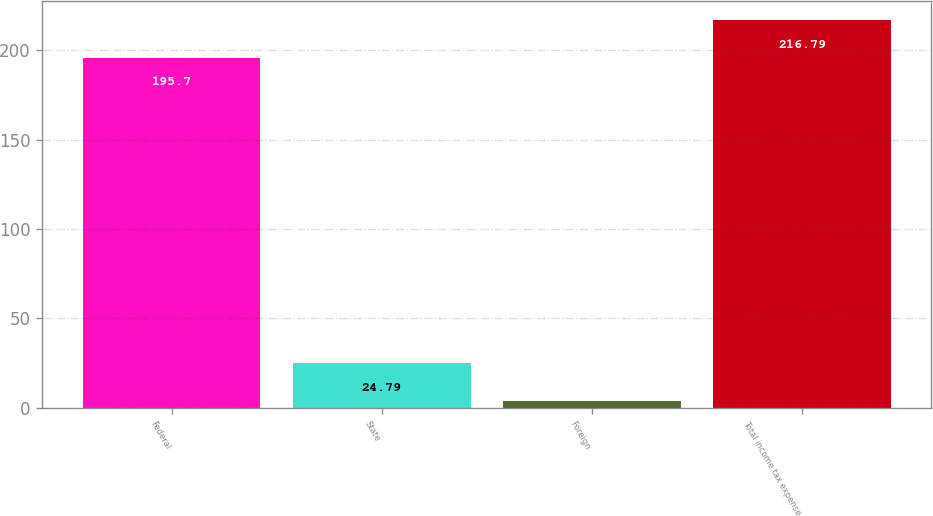Convert chart to OTSL. <chart><loc_0><loc_0><loc_500><loc_500><bar_chart><fcel>Federal<fcel>State<fcel>Foreign<fcel>Total income tax expense<nl><fcel>195.7<fcel>24.79<fcel>3.7<fcel>216.79<nl></chart> 